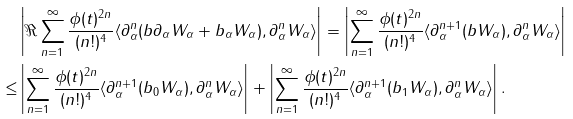Convert formula to latex. <formula><loc_0><loc_0><loc_500><loc_500>& \left | \Re \sum _ { n = 1 } ^ { \infty } \frac { \phi ( t ) ^ { 2 n } } { ( n ! ) ^ { 4 } } \langle \partial _ { \alpha } ^ { n } ( b \partial _ { \alpha } W _ { \alpha } + b _ { \alpha } W _ { \alpha } ) , \partial _ { \alpha } ^ { n } W _ { \alpha } \rangle \right | = \left | \sum _ { n = 1 } ^ { \infty } \frac { \phi ( t ) ^ { 2 n } } { ( n ! ) ^ { 4 } } \langle \partial _ { \alpha } ^ { n + 1 } ( b W _ { \alpha } ) , \partial _ { \alpha } ^ { n } W _ { \alpha } \rangle \right | \\ \leq & \left | \sum _ { n = 1 } ^ { \infty } \frac { \phi ( t ) ^ { 2 n } } { ( n ! ) ^ { 4 } } \langle \partial _ { \alpha } ^ { n + 1 } ( b _ { 0 } W _ { \alpha } ) , \partial _ { \alpha } ^ { n } W _ { \alpha } \rangle \right | + \left | \sum _ { n = 1 } ^ { \infty } \frac { \phi ( t ) ^ { 2 n } } { ( n ! ) ^ { 4 } } \langle \partial _ { \alpha } ^ { n + 1 } ( b _ { 1 } W _ { \alpha } ) , \partial _ { \alpha } ^ { n } W _ { \alpha } \rangle \right | .</formula> 